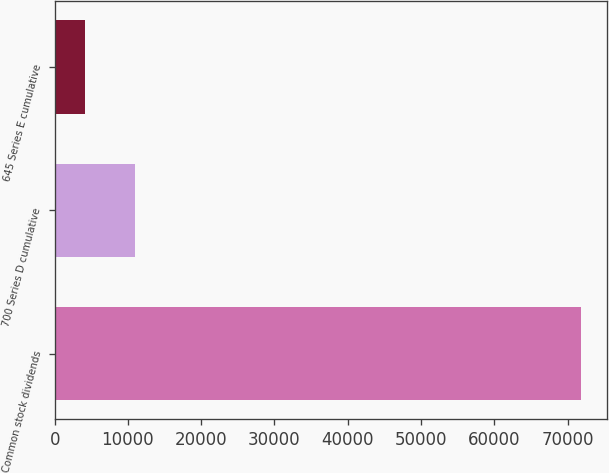Convert chart to OTSL. <chart><loc_0><loc_0><loc_500><loc_500><bar_chart><fcel>Common stock dividends<fcel>700 Series D cumulative<fcel>645 Series E cumulative<nl><fcel>71784<fcel>10951.2<fcel>4192<nl></chart> 